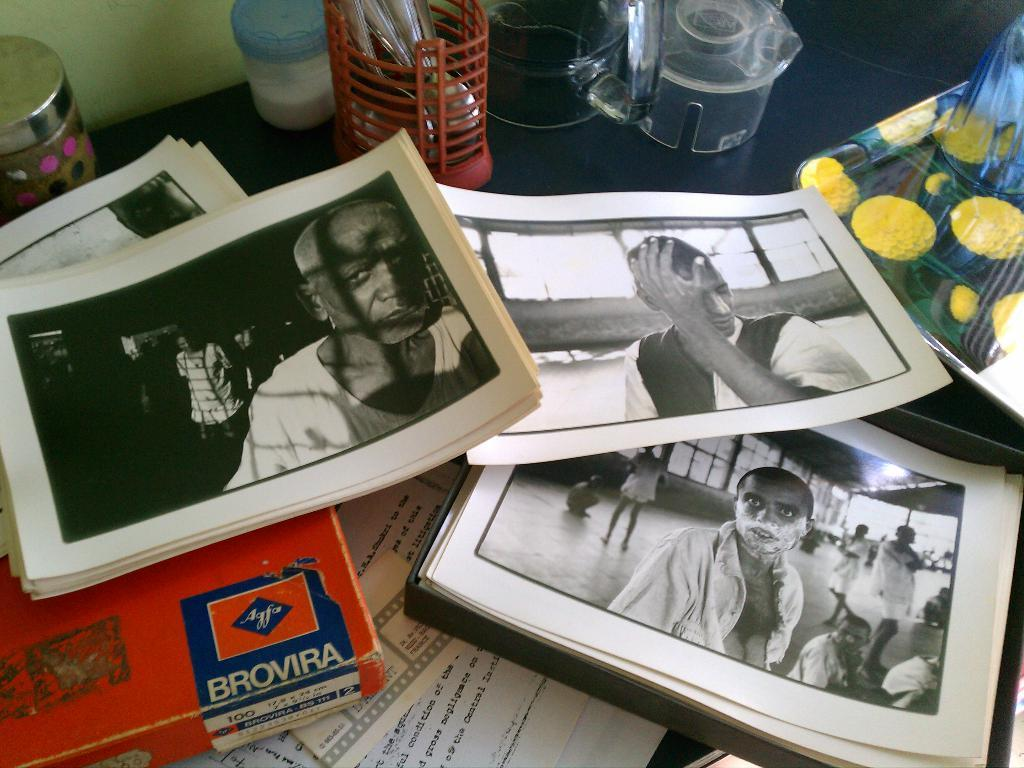What type of furniture is present in the image? There is a table in the image. What is placed on the table? There are many papers, a pen holder, containers, glass jars, and other objects on the table. Can you describe the pen holder? The pen holder is an object on the table that is used to hold pens or other writing instruments. What are the containers used for? The containers on the table might be used for storing or organizing various items. What are the glass jars used for? The glass jars on the table might be used for holding or displaying small objects or liquids. How does the group of people fly in the image? There are no people present in the image, let alone a group of people flying. 